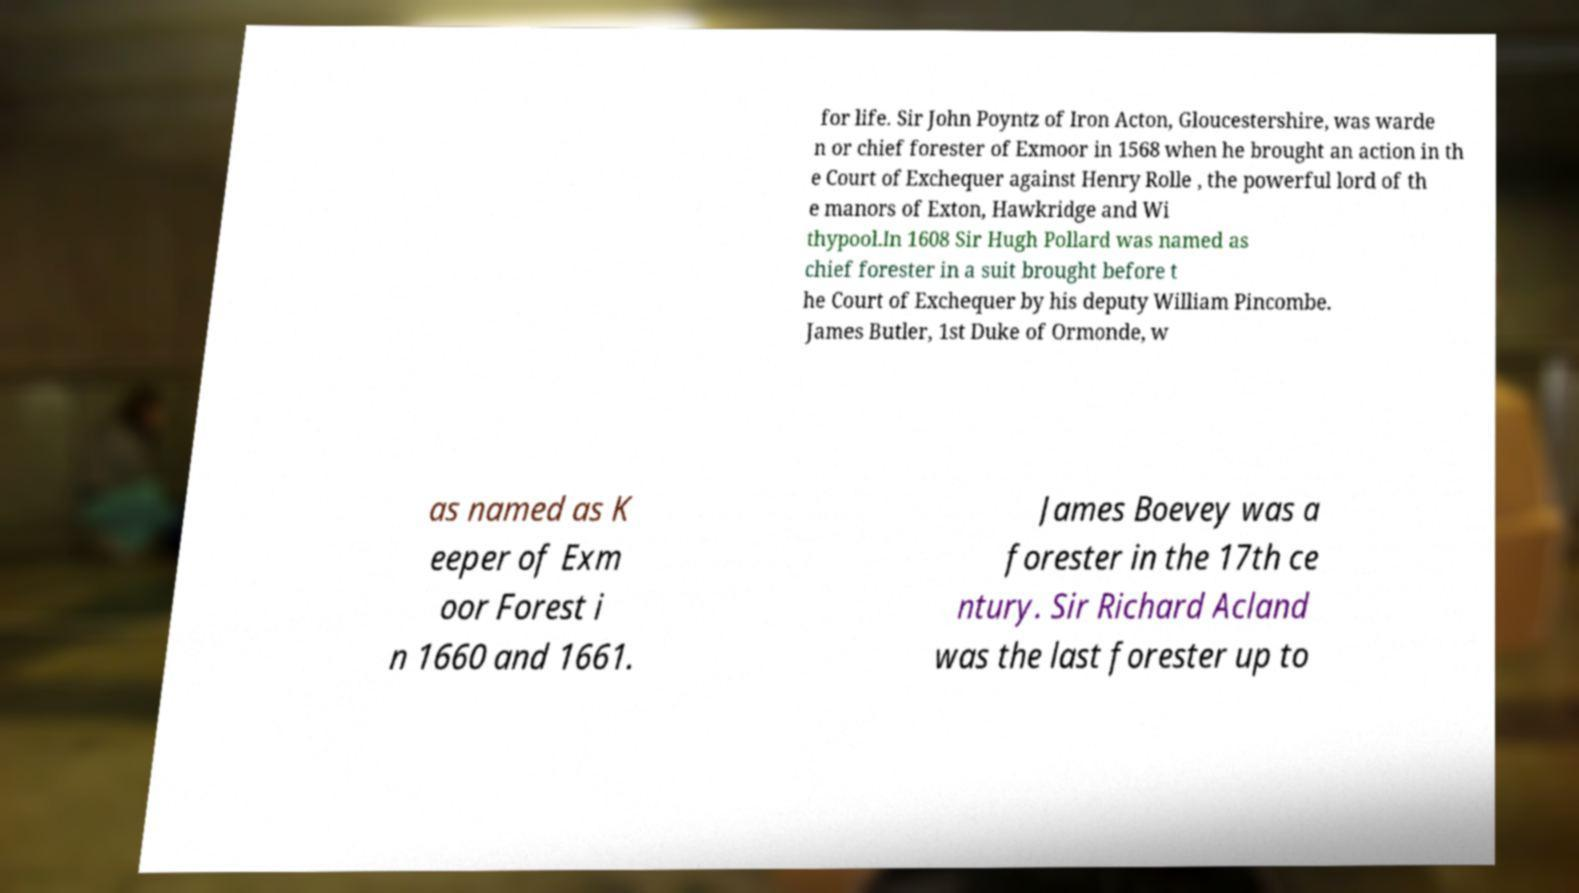Could you extract and type out the text from this image? for life. Sir John Poyntz of Iron Acton, Gloucestershire, was warde n or chief forester of Exmoor in 1568 when he brought an action in th e Court of Exchequer against Henry Rolle , the powerful lord of th e manors of Exton, Hawkridge and Wi thypool.In 1608 Sir Hugh Pollard was named as chief forester in a suit brought before t he Court of Exchequer by his deputy William Pincombe. James Butler, 1st Duke of Ormonde, w as named as K eeper of Exm oor Forest i n 1660 and 1661. James Boevey was a forester in the 17th ce ntury. Sir Richard Acland was the last forester up to 